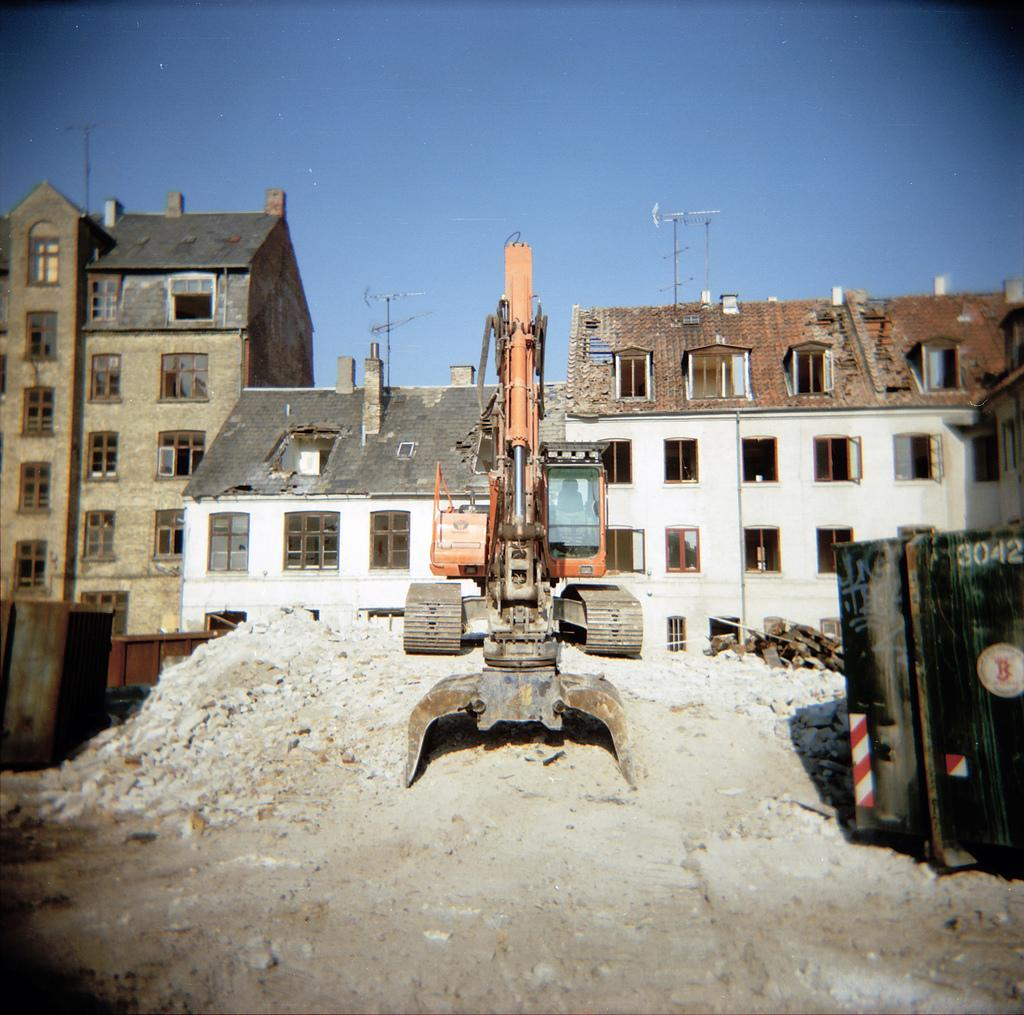What type of structures can be seen in the image? There are buildings in the image. What is located in the foreground of the image? There is a vehicle in the foreground of the image. What material is used for the walls in the image? The walls in the image are made of metal. What is visible at the top of the image? The sky is visible at the top of the image. What type of terrain is present at the bottom of the image? Mud is present at the bottom of the image. What type of coil is used to play baseball in the image? There is no coil or baseball present in the image. What items are listed on the metal walls in the image? There is no list or items listed on the metal walls in the image. 